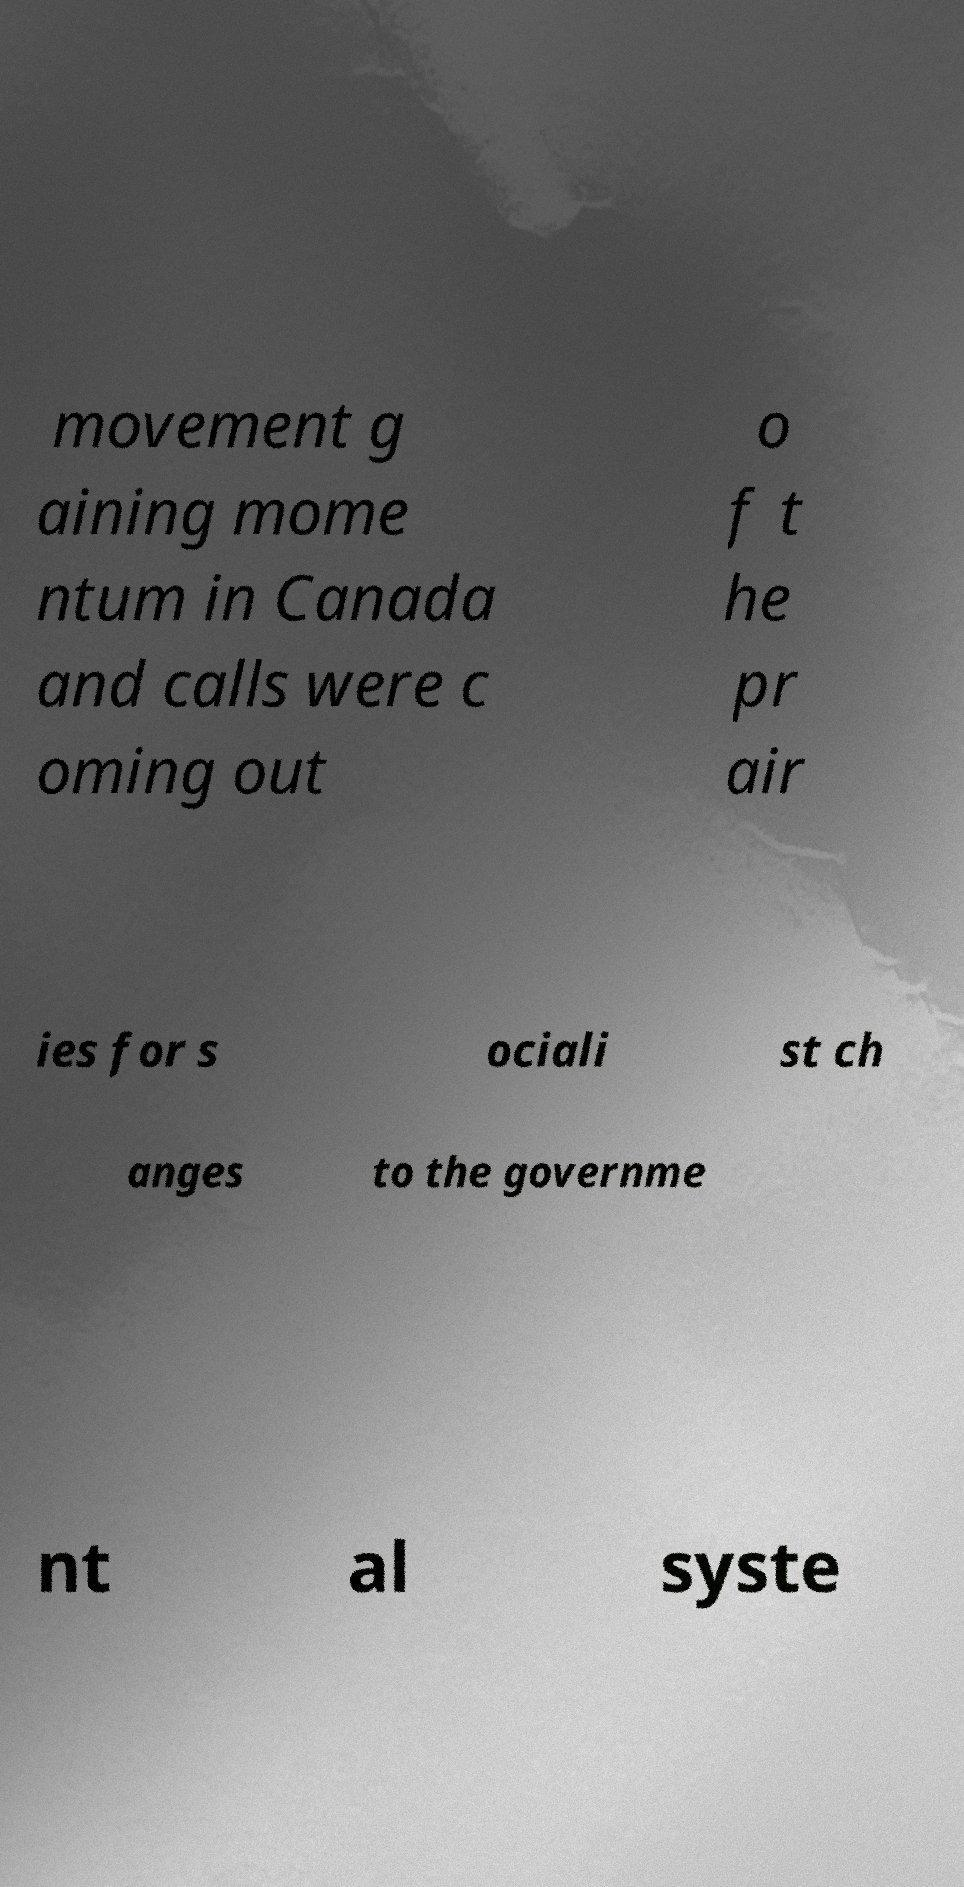Could you extract and type out the text from this image? movement g aining mome ntum in Canada and calls were c oming out o f t he pr air ies for s ociali st ch anges to the governme nt al syste 